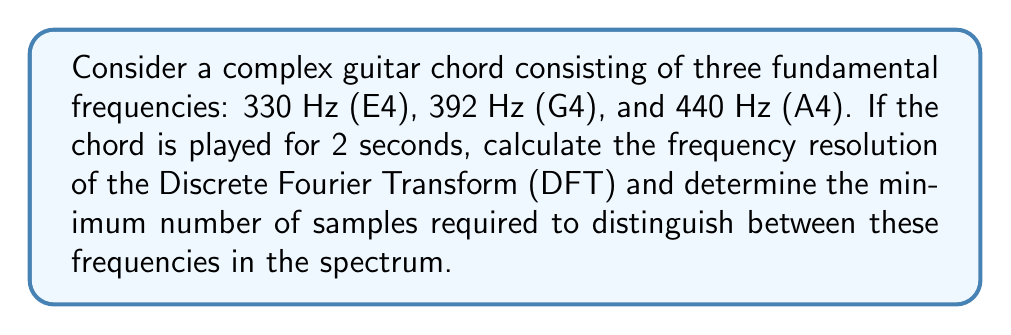Solve this math problem. To solve this problem, we need to understand the relationship between the time domain signal, sampling rate, and frequency resolution in the Fourier transform.

1. Frequency Resolution:
   The frequency resolution (Δf) of a DFT is given by:
   
   $$\Delta f = \frac{1}{T}$$
   
   where T is the total duration of the signal.

   In this case, T = 2 seconds, so:
   
   $$\Delta f = \frac{1}{2} = 0.5 \text{ Hz}$$

2. Nyquist Sampling Theorem:
   To accurately represent the highest frequency component (440 Hz), we need to sample at least twice that frequency:
   
   $$f_s \geq 2f_{max} = 2(440) = 880 \text{ Hz}$$

3. Number of Samples:
   The number of samples (N) is related to the sampling rate (f_s) and duration (T):
   
   $$N = f_s \cdot T$$

4. Frequency Bin Spacing:
   In the DFT, the frequency bin spacing is given by:
   
   $$\text{Bin Spacing} = \frac{f_s}{N} = \frac{1}{T} = \Delta f$$

5. Distinguishing Frequencies:
   To distinguish between the given frequencies, we need the bin spacing to be less than or equal to the smallest difference between any two frequencies:
   
   $$\text{Smallest difference} = 392 - 330 = 62 \text{ Hz}$$

   So, we need:
   
   $$\frac{f_s}{N} \leq 62 \text{ Hz}$$

6. Solving for N:
   $$N \geq \frac{f_s}{62}$$
   
   Using the minimum sampling rate from step 2:
   
   $$N \geq \frac{880}{62} \approx 14.19$$

   Since N must be an integer, we round up to the nearest whole number.
Answer: The frequency resolution of the DFT is 0.5 Hz, and the minimum number of samples required to distinguish between the given frequencies is 15. 